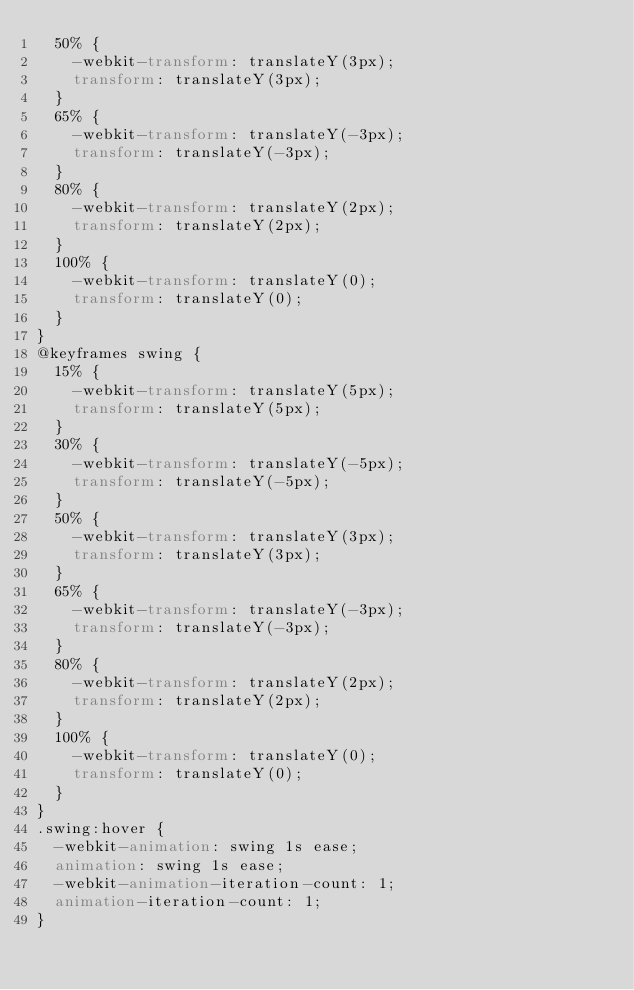Convert code to text. <code><loc_0><loc_0><loc_500><loc_500><_CSS_>  50% {
    -webkit-transform: translateY(3px);
    transform: translateY(3px);
  }
  65% {
    -webkit-transform: translateY(-3px);
    transform: translateY(-3px);
  }
  80% {
    -webkit-transform: translateY(2px);
    transform: translateY(2px);
  }
  100% {
    -webkit-transform: translateY(0);
    transform: translateY(0);
  }
}
@keyframes swing {
  15% {
    -webkit-transform: translateY(5px);
    transform: translateY(5px);
  }
  30% {
    -webkit-transform: translateY(-5px);
    transform: translateY(-5px);
  }
  50% {
    -webkit-transform: translateY(3px);
    transform: translateY(3px);
  }
  65% {
    -webkit-transform: translateY(-3px);
    transform: translateY(-3px);
  }
  80% {
    -webkit-transform: translateY(2px);
    transform: translateY(2px);
  }
  100% {
    -webkit-transform: translateY(0);
    transform: translateY(0);
  }
}
.swing:hover {
  -webkit-animation: swing 1s ease;
  animation: swing 1s ease;
  -webkit-animation-iteration-count: 1;
  animation-iteration-count: 1;
}
</code> 